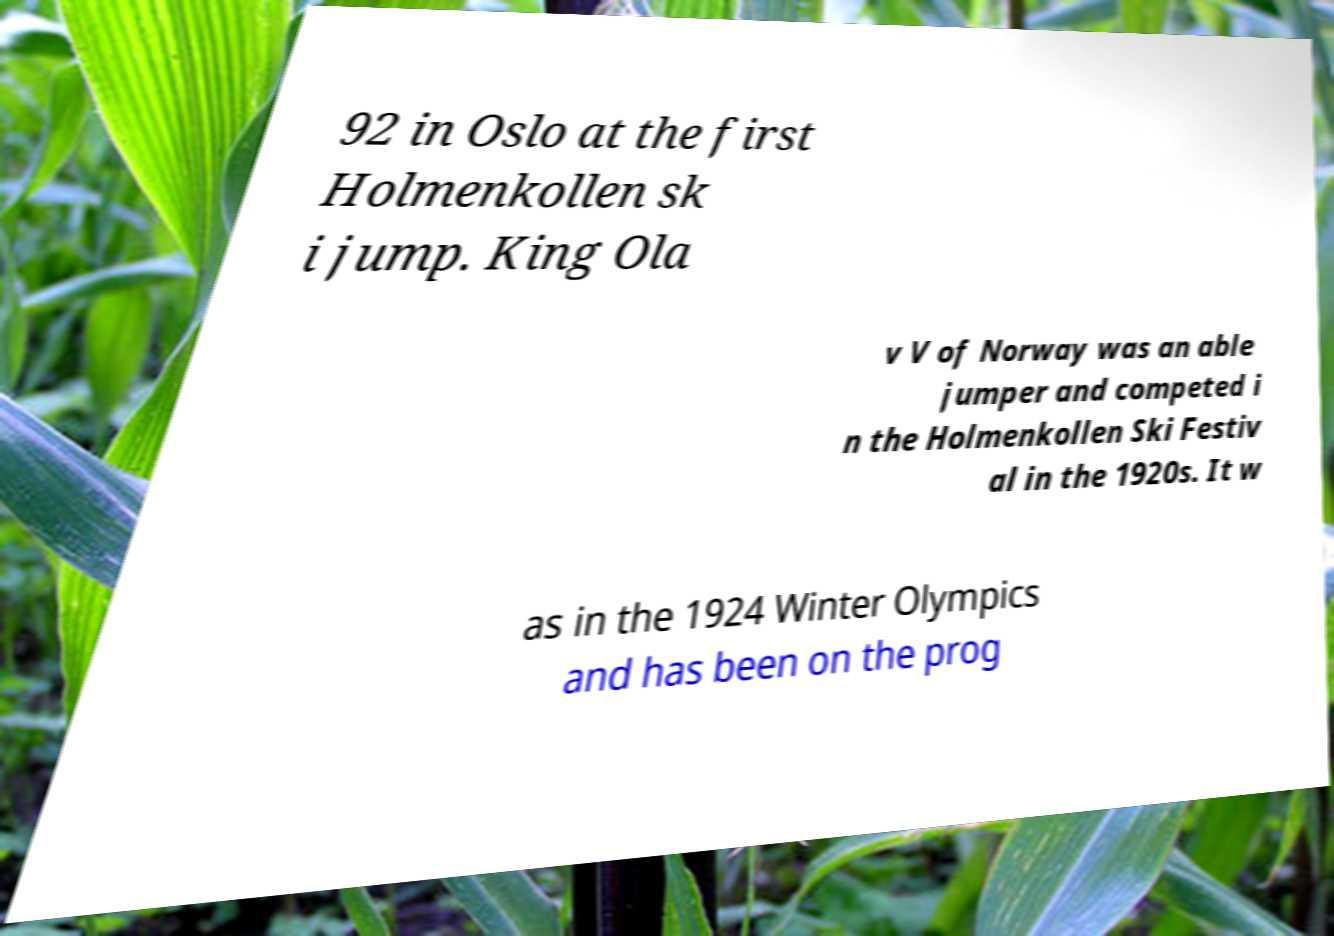What messages or text are displayed in this image? I need them in a readable, typed format. 92 in Oslo at the first Holmenkollen sk i jump. King Ola v V of Norway was an able jumper and competed i n the Holmenkollen Ski Festiv al in the 1920s. It w as in the 1924 Winter Olympics and has been on the prog 